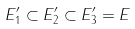Convert formula to latex. <formula><loc_0><loc_0><loc_500><loc_500>E _ { 1 } ^ { \prime } \subset E _ { 2 } ^ { \prime } \subset E _ { 3 } ^ { \prime } = E</formula> 